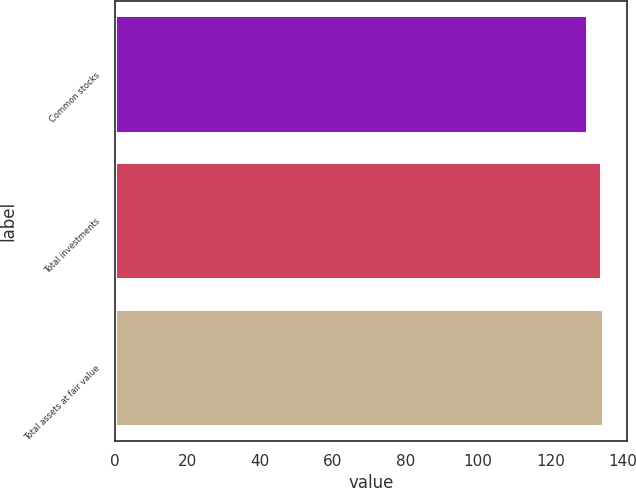Convert chart to OTSL. <chart><loc_0><loc_0><loc_500><loc_500><bar_chart><fcel>Common stocks<fcel>Total investments<fcel>Total assets at fair value<nl><fcel>130<fcel>134<fcel>134.4<nl></chart> 